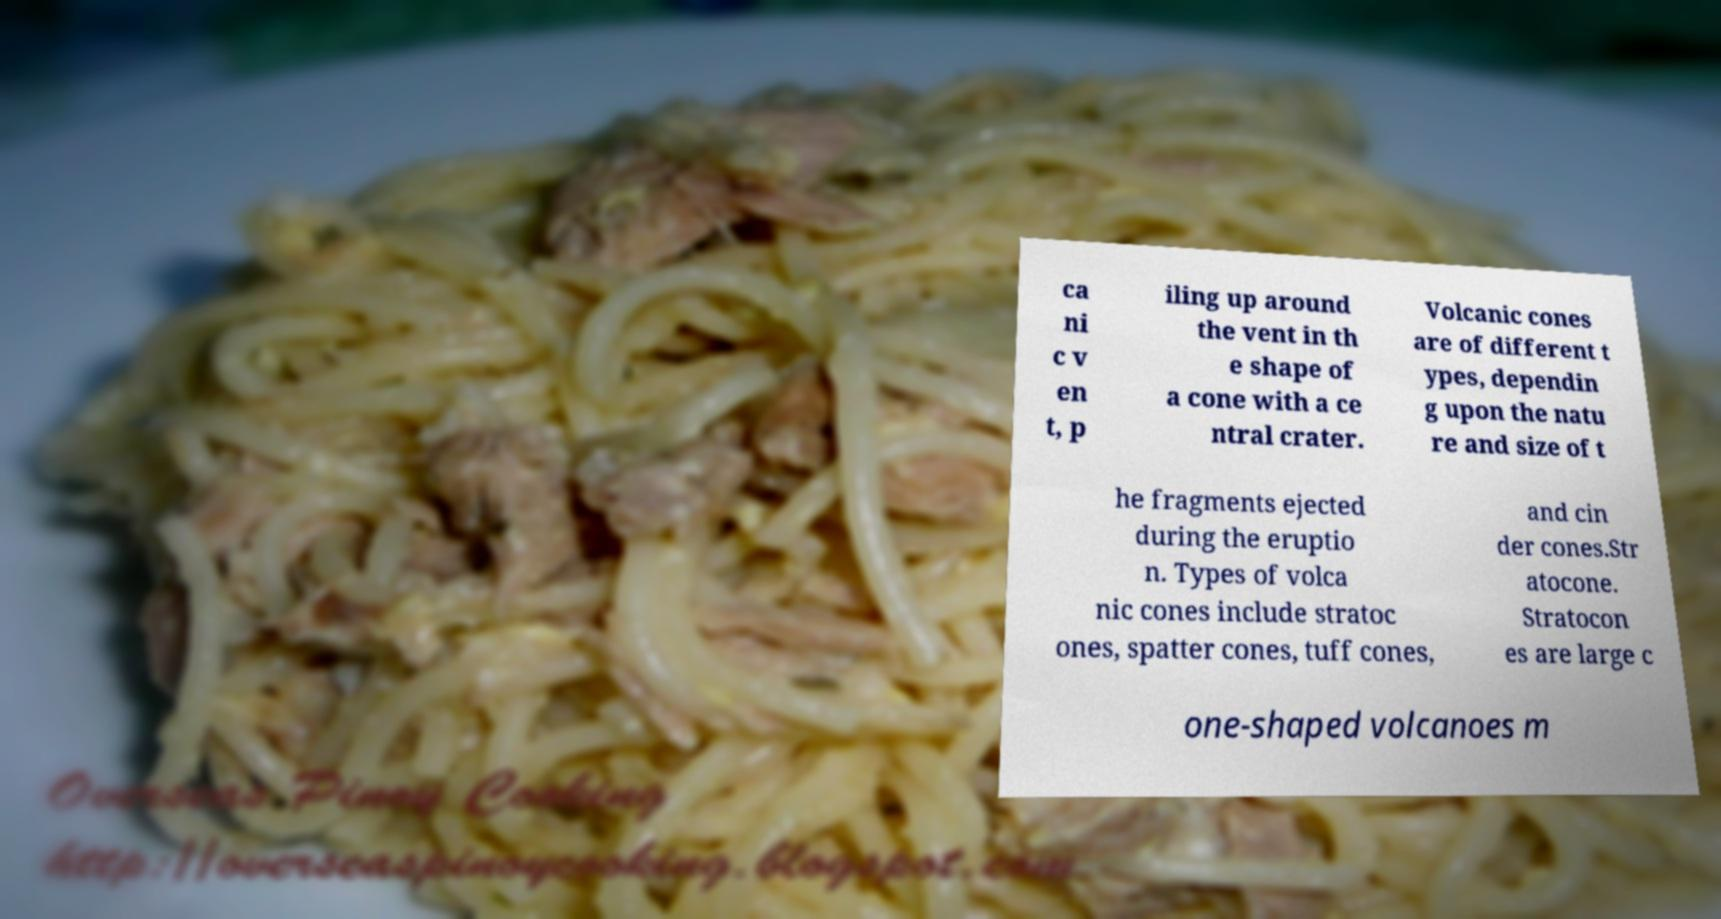Could you extract and type out the text from this image? ca ni c v en t, p iling up around the vent in th e shape of a cone with a ce ntral crater. Volcanic cones are of different t ypes, dependin g upon the natu re and size of t he fragments ejected during the eruptio n. Types of volca nic cones include stratoc ones, spatter cones, tuff cones, and cin der cones.Str atocone. Stratocon es are large c one-shaped volcanoes m 